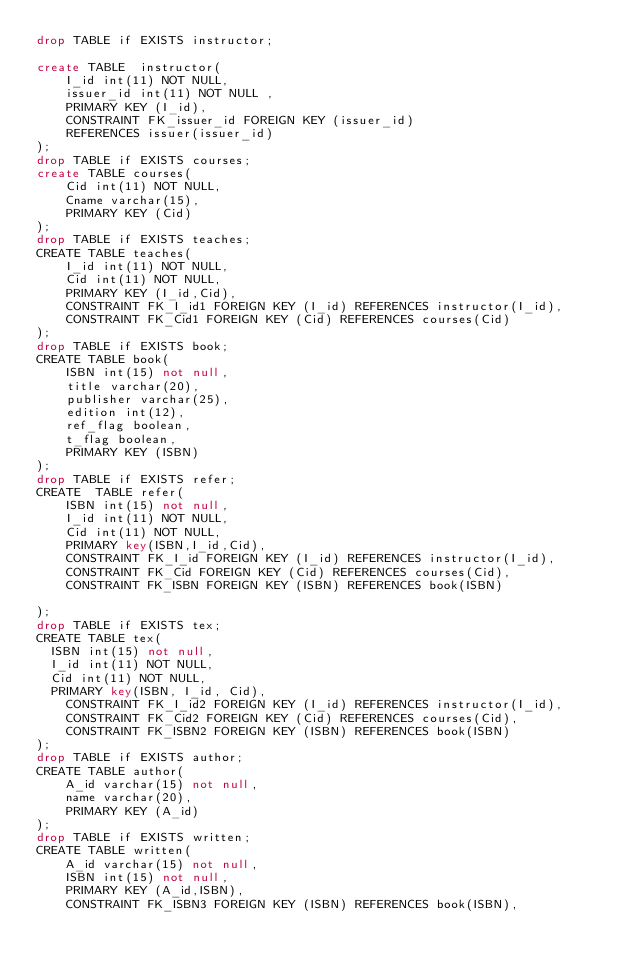Convert code to text. <code><loc_0><loc_0><loc_500><loc_500><_SQL_>drop TABLE if EXISTS instructor;

create TABLE  instructor(
    I_id int(11) NOT NULL,
    issuer_id int(11) NOT NULL ,
    PRIMARY KEY (I_id),
    CONSTRAINT FK_issuer_id FOREIGN KEY (issuer_id) 
    REFERENCES issuer(issuer_id)
);
drop TABLE if EXISTS courses;
create TABLE courses(
    Cid int(11) NOT NULL,
    Cname varchar(15),
    PRIMARY KEY (Cid)
);
drop TABLE if EXISTS teaches;
CREATE TABLE teaches(
    I_id int(11) NOT NULL,
    Cid int(11) NOT NULL,
    PRIMARY KEY (I_id,Cid),
    CONSTRAINT FK_I_id1 FOREIGN KEY (I_id) REFERENCES instructor(I_id),
    CONSTRAINT FK_Cid1 FOREIGN KEY (Cid) REFERENCES courses(Cid)
);
drop TABLE if EXISTS book;
CREATE TABLE book(
    ISBN int(15) not null,
    title varchar(20),
    publisher varchar(25),
    edition int(12),
    ref_flag boolean,
    t_flag boolean,
    PRIMARY KEY (ISBN)
);
drop TABLE if EXISTS refer;
CREATE  TABLE refer(
    ISBN int(15) not null,
    I_id int(11) NOT NULL,
    Cid int(11) NOT NULL,
    PRIMARY key(ISBN,I_id,Cid),
    CONSTRAINT FK_I_id FOREIGN KEY (I_id) REFERENCES instructor(I_id),
    CONSTRAINT FK_Cid FOREIGN KEY (Cid) REFERENCES courses(Cid),
    CONSTRAINT FK_ISBN FOREIGN KEY (ISBN) REFERENCES book(ISBN)

);
drop TABLE if EXISTS tex;
CREATE TABLE tex(
  ISBN int(15) not null,
  I_id int(11) NOT NULL,
  Cid int(11) NOT NULL,
  PRIMARY key(ISBN, I_id, Cid),
    CONSTRAINT FK_I_id2 FOREIGN KEY (I_id) REFERENCES instructor(I_id),
    CONSTRAINT FK_Cid2 FOREIGN KEY (Cid) REFERENCES courses(Cid),
    CONSTRAINT FK_ISBN2 FOREIGN KEY (ISBN) REFERENCES book(ISBN)
);
drop TABLE if EXISTS author;
CREATE TABLE author(
    A_id varchar(15) not null,
    name varchar(20),
    PRIMARY KEY (A_id)
);
drop TABLE if EXISTS written;
CREATE TABLE written(
    A_id varchar(15) not null,
    ISBN int(15) not null,
    PRIMARY KEY (A_id,ISBN),
    CONSTRAINT FK_ISBN3 FOREIGN KEY (ISBN) REFERENCES book(ISBN),</code> 